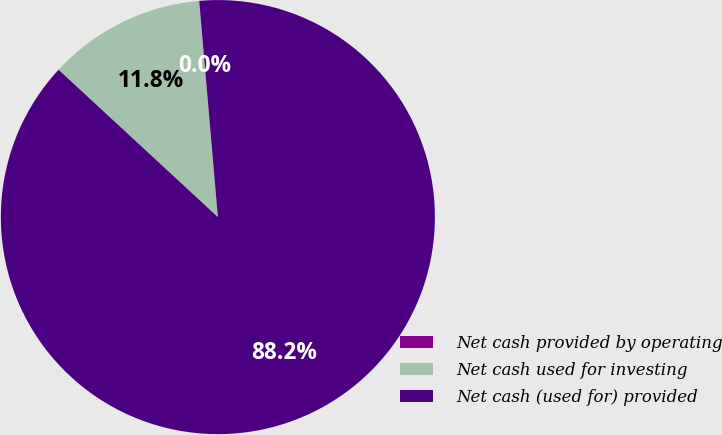<chart> <loc_0><loc_0><loc_500><loc_500><pie_chart><fcel>Net cash provided by operating<fcel>Net cash used for investing<fcel>Net cash (used for) provided<nl><fcel>0.0%<fcel>11.75%<fcel>88.25%<nl></chart> 